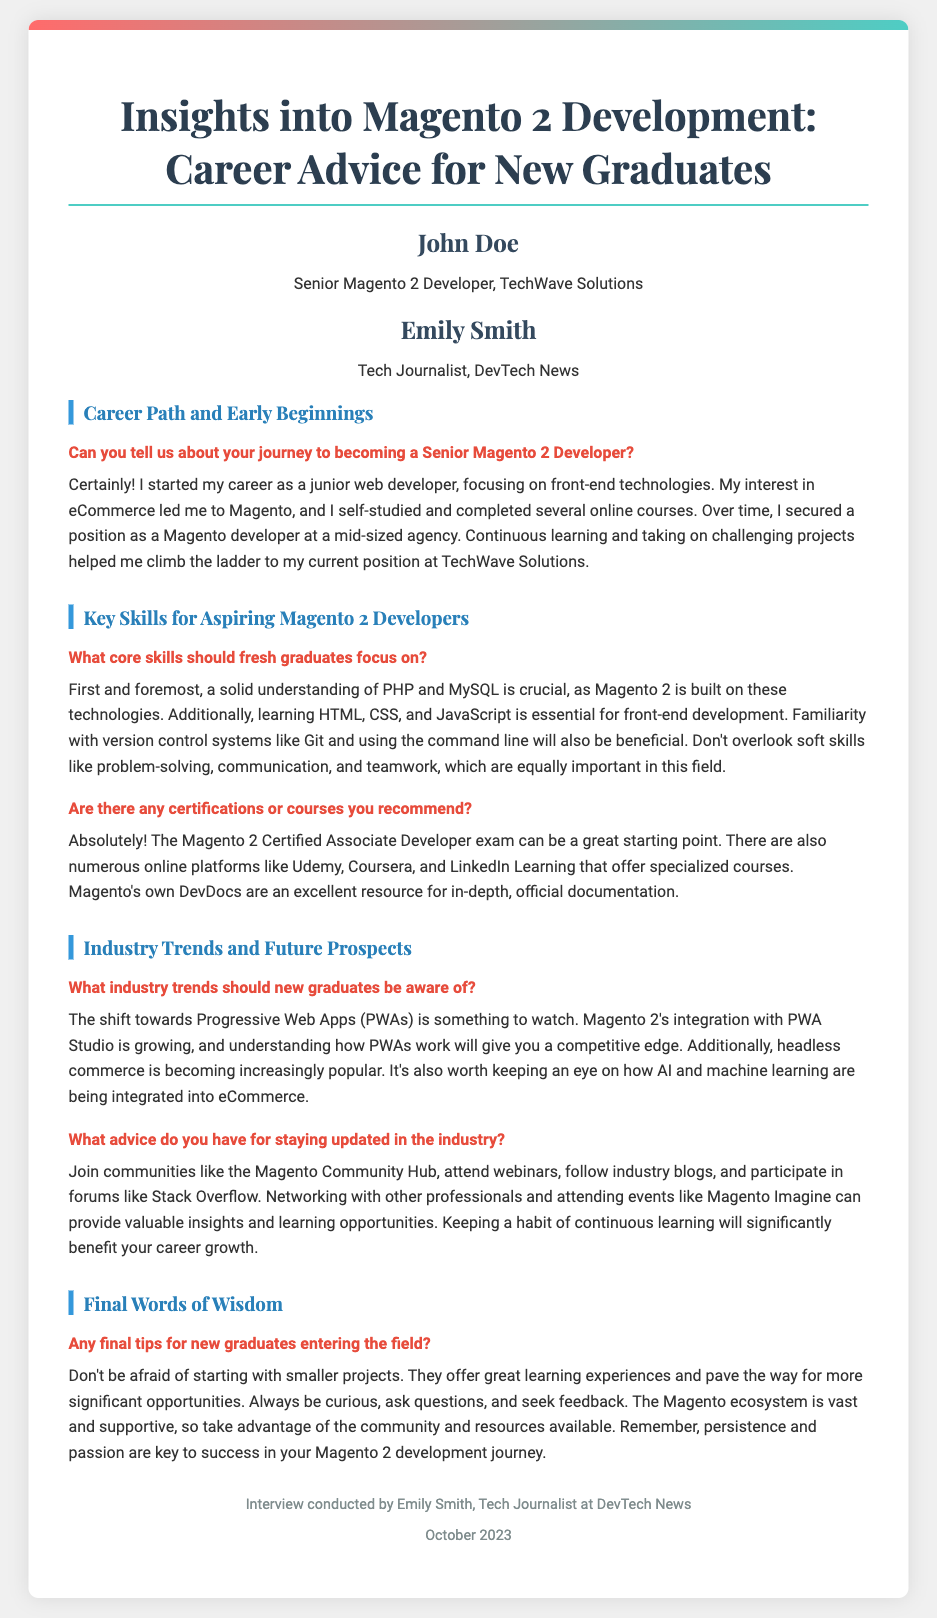What is the name of the interviewee? The interviewee is introduced at the beginning of the document, who is John Doe.
Answer: John Doe What is the title of the interviewee? The title of John Doe is mentioned in his introduction, which is Senior Magento 2 Developer.
Answer: Senior Magento 2 Developer Who conducted the interview? The interviewer is named in the document as Emily Smith.
Answer: Emily Smith What should fresh graduates learn first? The answer is found in the skills section where PHP and MySQL are emphasized as essential skills.
Answer: PHP and MySQL What certification is recommended for new graduates? The document mentions a specific certification that can benefit new graduates: the Magento 2 Certified Associate Developer exam.
Answer: Magento 2 Certified Associate Developer exam What industry trend involves Progressive Web Apps? This trend is highlighted in the industry trends section mentioning its relevance to Magento 2 development.
Answer: PWA What type of projects does John Doe suggest starting with? The final advice section discusses starting small, emphasizing the benefit of smaller projects.
Answer: Smaller projects What is a soft skill mentioned as important in the field? The document emphasizes that communication is one of the soft skills critical in the field.
Answer: Communication When was the interview conducted? The footer of the document states when the interview took place, which is October 2023.
Answer: October 2023 